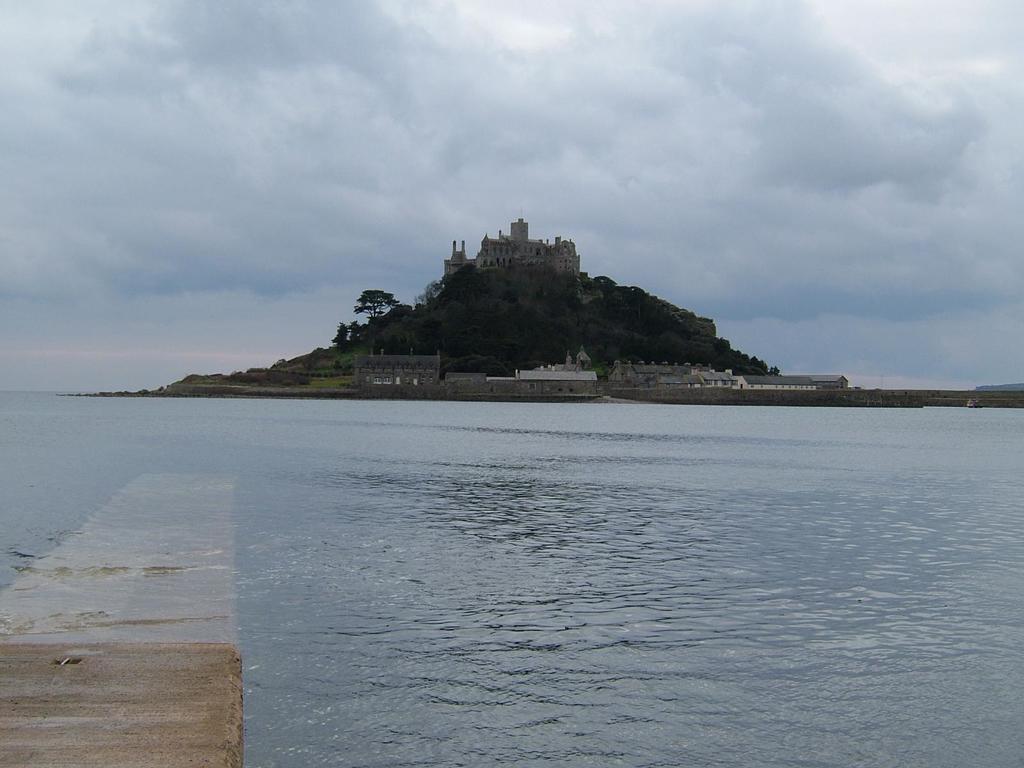Can you describe this image briefly? In this image we can see buildings on the hill, trees, water and sky with clouds. 